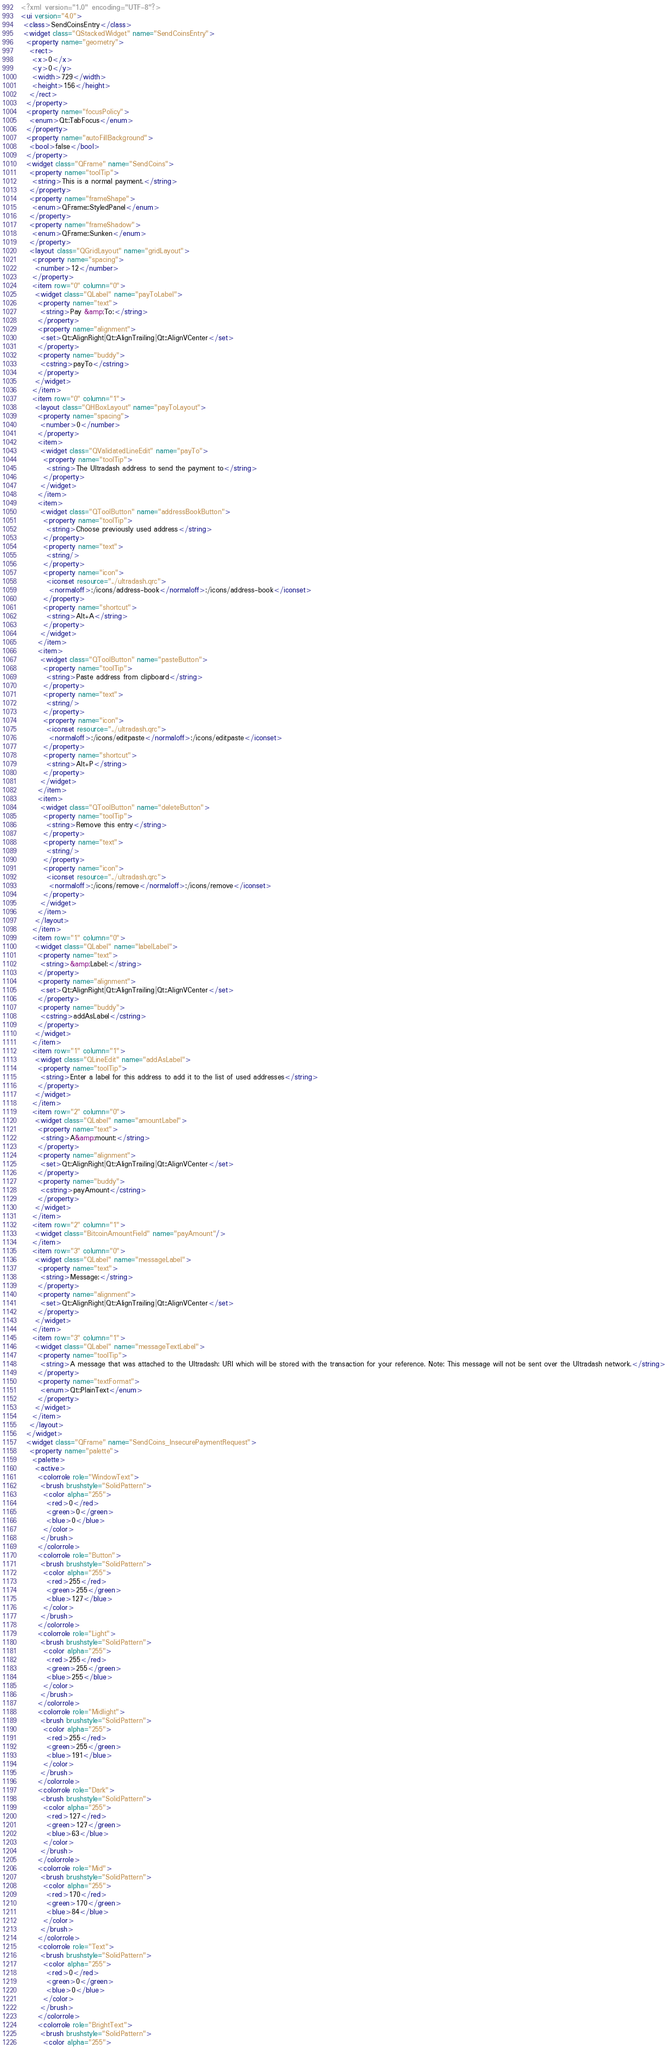<code> <loc_0><loc_0><loc_500><loc_500><_XML_><?xml version="1.0" encoding="UTF-8"?>
<ui version="4.0">
 <class>SendCoinsEntry</class>
 <widget class="QStackedWidget" name="SendCoinsEntry">
  <property name="geometry">
   <rect>
    <x>0</x>
    <y>0</y>
    <width>729</width>
    <height>156</height>
   </rect>
  </property>
  <property name="focusPolicy">
   <enum>Qt::TabFocus</enum>
  </property>
  <property name="autoFillBackground">
   <bool>false</bool>
  </property>
  <widget class="QFrame" name="SendCoins">
   <property name="toolTip">
    <string>This is a normal payment.</string>
   </property>
   <property name="frameShape">
    <enum>QFrame::StyledPanel</enum>
   </property>
   <property name="frameShadow">
    <enum>QFrame::Sunken</enum>
   </property>
   <layout class="QGridLayout" name="gridLayout">
    <property name="spacing">
     <number>12</number>
    </property>
    <item row="0" column="0">
     <widget class="QLabel" name="payToLabel">
      <property name="text">
       <string>Pay &amp;To:</string>
      </property>
      <property name="alignment">
       <set>Qt::AlignRight|Qt::AlignTrailing|Qt::AlignVCenter</set>
      </property>
      <property name="buddy">
       <cstring>payTo</cstring>
      </property>
     </widget>
    </item>
    <item row="0" column="1">
     <layout class="QHBoxLayout" name="payToLayout">
      <property name="spacing">
       <number>0</number>
      </property>
      <item>
       <widget class="QValidatedLineEdit" name="payTo">
        <property name="toolTip">
         <string>The Ultradash address to send the payment to</string>
        </property>
       </widget>
      </item>
      <item>
       <widget class="QToolButton" name="addressBookButton">
        <property name="toolTip">
         <string>Choose previously used address</string>
        </property>
        <property name="text">
         <string/>
        </property>
        <property name="icon">
         <iconset resource="../ultradash.qrc">
          <normaloff>:/icons/address-book</normaloff>:/icons/address-book</iconset>
        </property>
        <property name="shortcut">
         <string>Alt+A</string>
        </property>
       </widget>
      </item>
      <item>
       <widget class="QToolButton" name="pasteButton">
        <property name="toolTip">
         <string>Paste address from clipboard</string>
        </property>
        <property name="text">
         <string/>
        </property>
        <property name="icon">
         <iconset resource="../ultradash.qrc">
          <normaloff>:/icons/editpaste</normaloff>:/icons/editpaste</iconset>
        </property>
        <property name="shortcut">
         <string>Alt+P</string>
        </property>
       </widget>
      </item>
      <item>
       <widget class="QToolButton" name="deleteButton">
        <property name="toolTip">
         <string>Remove this entry</string>
        </property>
        <property name="text">
         <string/>
        </property>
        <property name="icon">
         <iconset resource="../ultradash.qrc">
          <normaloff>:/icons/remove</normaloff>:/icons/remove</iconset>
        </property>
       </widget>
      </item>
     </layout>
    </item>
    <item row="1" column="0">
     <widget class="QLabel" name="labelLabel">
      <property name="text">
       <string>&amp;Label:</string>
      </property>
      <property name="alignment">
       <set>Qt::AlignRight|Qt::AlignTrailing|Qt::AlignVCenter</set>
      </property>
      <property name="buddy">
       <cstring>addAsLabel</cstring>
      </property>
     </widget>
    </item>
    <item row="1" column="1">
     <widget class="QLineEdit" name="addAsLabel">
      <property name="toolTip">
       <string>Enter a label for this address to add it to the list of used addresses</string>
      </property>
     </widget>
    </item>
    <item row="2" column="0">
     <widget class="QLabel" name="amountLabel">
      <property name="text">
       <string>A&amp;mount:</string>
      </property>
      <property name="alignment">
       <set>Qt::AlignRight|Qt::AlignTrailing|Qt::AlignVCenter</set>
      </property>
      <property name="buddy">
       <cstring>payAmount</cstring>
      </property>
     </widget>
    </item>
    <item row="2" column="1">
     <widget class="BitcoinAmountField" name="payAmount"/>
    </item>
    <item row="3" column="0">
     <widget class="QLabel" name="messageLabel">
      <property name="text">
       <string>Message:</string>
      </property>
      <property name="alignment">
       <set>Qt::AlignRight|Qt::AlignTrailing|Qt::AlignVCenter</set>
      </property>
     </widget>
    </item>
    <item row="3" column="1">
     <widget class="QLabel" name="messageTextLabel">
      <property name="toolTip">
       <string>A message that was attached to the Ultradash: URI which will be stored with the transaction for your reference. Note: This message will not be sent over the Ultradash network.</string>
      </property>
      <property name="textFormat">
       <enum>Qt::PlainText</enum>
      </property>
     </widget>
    </item>
   </layout>
  </widget>
  <widget class="QFrame" name="SendCoins_InsecurePaymentRequest">
   <property name="palette">
    <palette>
     <active>
      <colorrole role="WindowText">
       <brush brushstyle="SolidPattern">
        <color alpha="255">
         <red>0</red>
         <green>0</green>
         <blue>0</blue>
        </color>
       </brush>
      </colorrole>
      <colorrole role="Button">
       <brush brushstyle="SolidPattern">
        <color alpha="255">
         <red>255</red>
         <green>255</green>
         <blue>127</blue>
        </color>
       </brush>
      </colorrole>
      <colorrole role="Light">
       <brush brushstyle="SolidPattern">
        <color alpha="255">
         <red>255</red>
         <green>255</green>
         <blue>255</blue>
        </color>
       </brush>
      </colorrole>
      <colorrole role="Midlight">
       <brush brushstyle="SolidPattern">
        <color alpha="255">
         <red>255</red>
         <green>255</green>
         <blue>191</blue>
        </color>
       </brush>
      </colorrole>
      <colorrole role="Dark">
       <brush brushstyle="SolidPattern">
        <color alpha="255">
         <red>127</red>
         <green>127</green>
         <blue>63</blue>
        </color>
       </brush>
      </colorrole>
      <colorrole role="Mid">
       <brush brushstyle="SolidPattern">
        <color alpha="255">
         <red>170</red>
         <green>170</green>
         <blue>84</blue>
        </color>
       </brush>
      </colorrole>
      <colorrole role="Text">
       <brush brushstyle="SolidPattern">
        <color alpha="255">
         <red>0</red>
         <green>0</green>
         <blue>0</blue>
        </color>
       </brush>
      </colorrole>
      <colorrole role="BrightText">
       <brush brushstyle="SolidPattern">
        <color alpha="255"></code> 